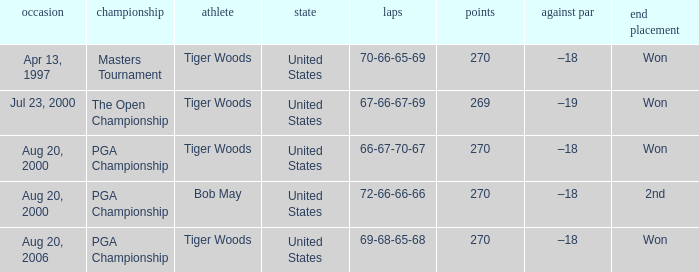What country hosts the tournament the open championship? United States. 